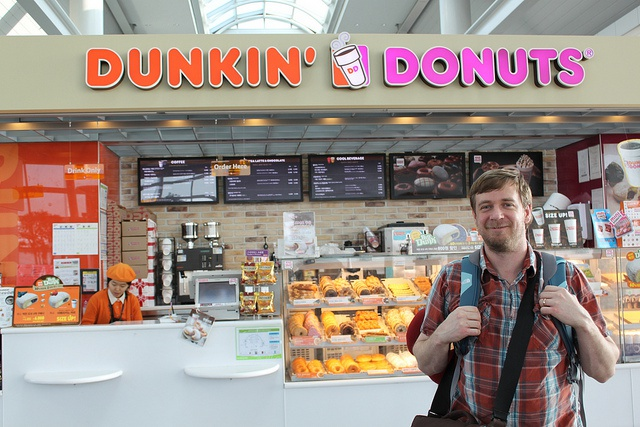Describe the objects in this image and their specific colors. I can see people in white, black, maroon, and gray tones, donut in white, khaki, orange, and gold tones, handbag in white, black, maroon, gray, and lightgray tones, people in white, red, brown, and gray tones, and backpack in white, blue, gray, darkgray, and black tones in this image. 